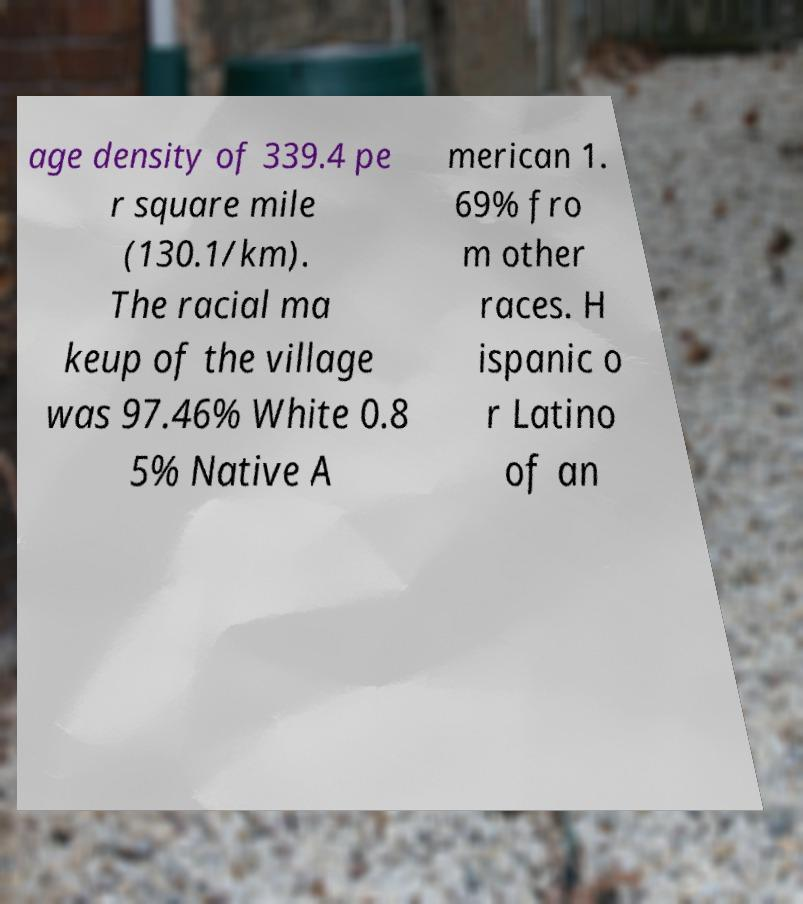Please identify and transcribe the text found in this image. age density of 339.4 pe r square mile (130.1/km). The racial ma keup of the village was 97.46% White 0.8 5% Native A merican 1. 69% fro m other races. H ispanic o r Latino of an 